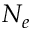Convert formula to latex. <formula><loc_0><loc_0><loc_500><loc_500>N _ { e }</formula> 